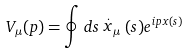Convert formula to latex. <formula><loc_0><loc_0><loc_500><loc_500>V _ { \mu } ( p ) = \oint d s \stackrel { . } { x } _ { \mu } ( s ) e ^ { i p x ( s ) }</formula> 